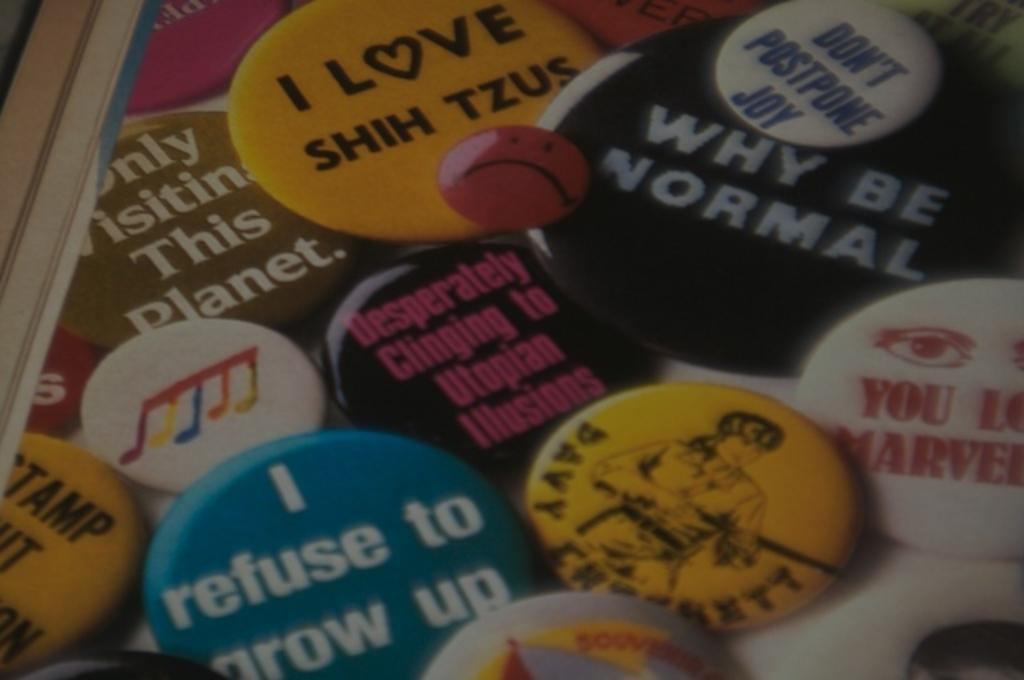What objects are present on the surface in the image? There are badges on the surface in the image. What other object can be seen in the image? There is a wooden stick in the image. What advice does the lawyer give to the manager in the image? There is no lawyer or manager present in the image; it only features badges and a wooden stick. How many bubbles are floating around the badges in the image? There are no bubbles present in the image; it only features badges and a wooden stick. 